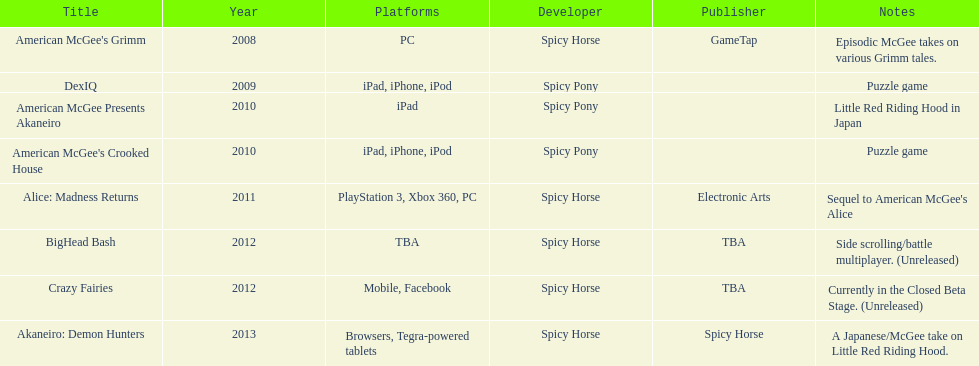What is the total number of games developed by spicy horse? 5. 